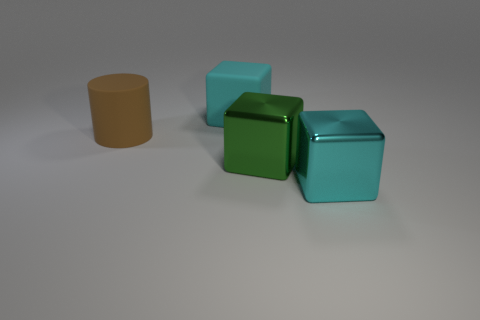There is a cube that is behind the large thing that is on the left side of the cyan block on the left side of the cyan metal object; what is its color?
Offer a terse response. Cyan. What color is the matte cylinder that is the same size as the matte cube?
Provide a short and direct response. Brown. There is a matte thing that is behind the thing that is to the left of the cyan cube that is behind the cyan shiny thing; what shape is it?
Give a very brief answer. Cube. What number of objects are big gray rubber cylinders or objects that are to the right of the large green metallic cube?
Your response must be concise. 1. Is the size of the cube that is behind the green shiny block the same as the green thing?
Offer a terse response. Yes. There is a cyan object that is behind the big cylinder; what is its material?
Offer a very short reply. Rubber. Are there an equal number of green objects that are in front of the large matte block and big things that are behind the big brown object?
Provide a short and direct response. Yes. The large rubber object that is the same shape as the large cyan shiny thing is what color?
Provide a short and direct response. Cyan. Is there anything else that is the same color as the big matte cube?
Your answer should be very brief. Yes. What number of shiny things are either cyan things or brown cylinders?
Your answer should be very brief. 1. 